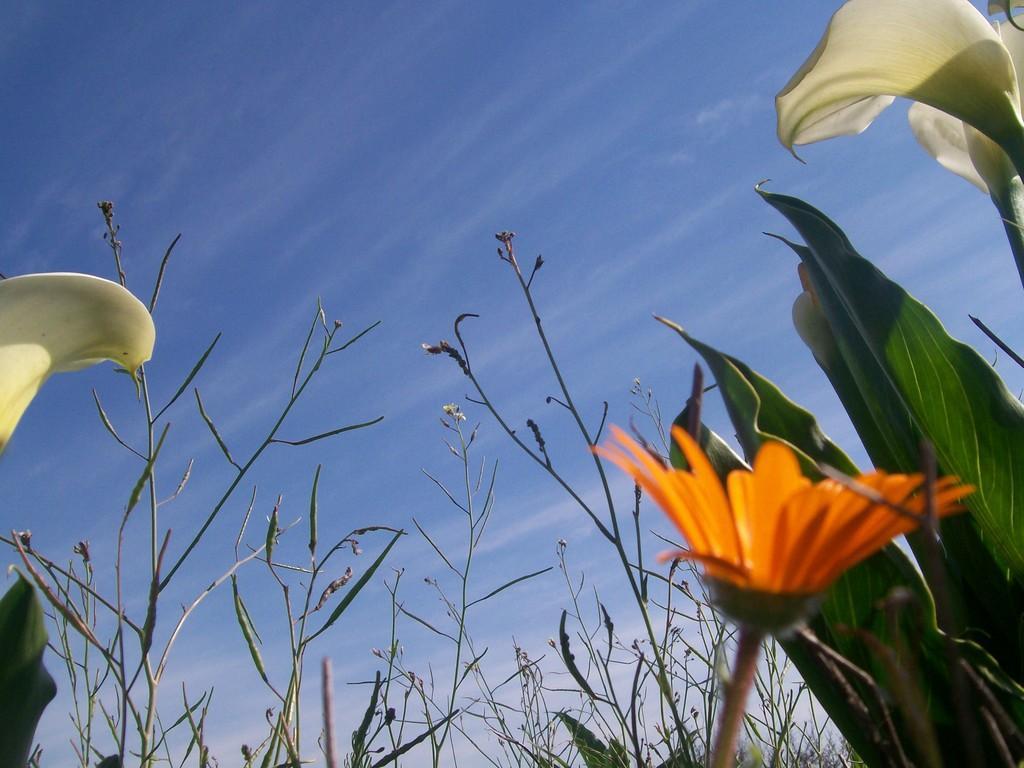Please provide a concise description of this image. In this image, there is an outside view. In the foreground, there are some plants. There is a flower in the bottom right of the image. In the background, there is a sky. 